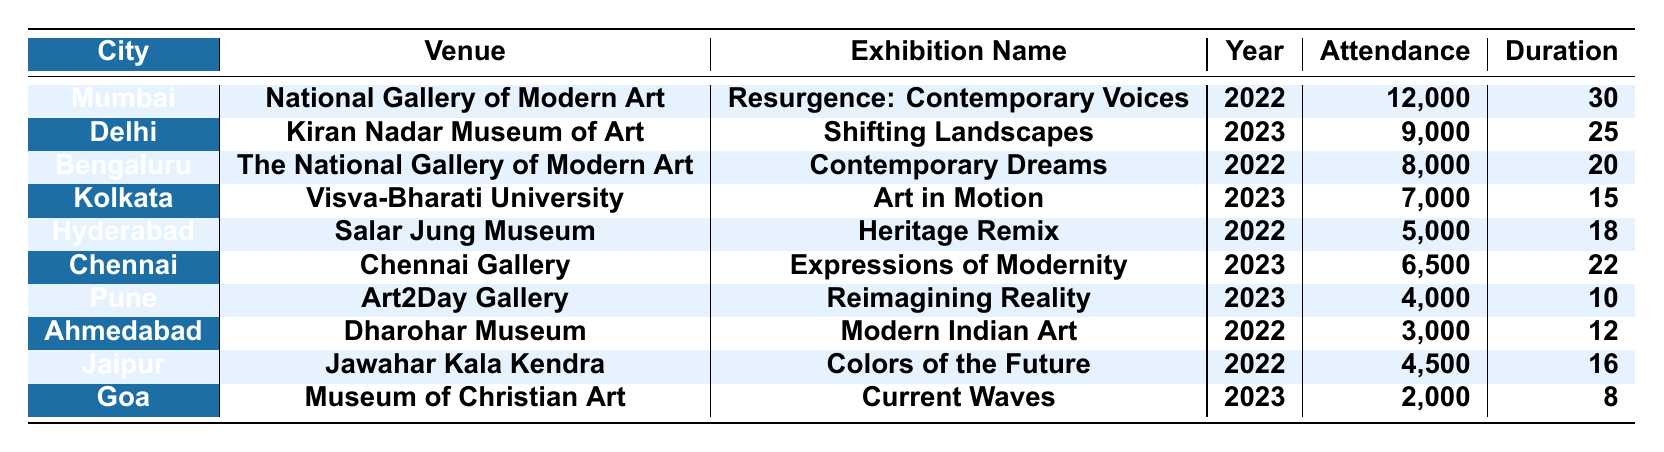What city had the highest attendance at an exhibition? Mumbai had the highest attendance at the "Resurgence: Contemporary Voices" exhibition with 12,000 attendees.
Answer: Mumbai Which exhibition had the lowest attendance? The "Current Waves" exhibition in Goa had the lowest attendance with 2,000 attendees.
Answer: Current Waves What is the total attendance for exhibitions in Chennai and Pune? The attendance for the "Expressions of Modernity" in Chennai is 6,500 and for "Reimagining Reality" in Pune is 4,000. Adding these, 6,500 + 4,000 = 10,500.
Answer: 10,500 How many cities had exhibitions in 2023? The cities that had exhibitions in 2023 are Delhi, Kolkata, Chennai, Pune, and Goa, totaling 5 cities.
Answer: 5 Which exhibition had a duration of more than 20 days? The "Resurgence: Contemporary Voices" in Mumbai was the only exhibition lasting 30 days, which is more than 20 days.
Answer: Resurgence: Contemporary Voices What was the average attendance for exhibitions in 2022? The attendances for 2022 are 12,000 (Mumbai), 8,000 (Bengaluru), 5,000 (Hyderabad), 3,000 (Ahmedabad), and 4,500 (Jaipur). Adding these gives 12,000 + 8,000 + 5,000 + 3,000 + 4,500 = 32,500. Dividing by 5 (the number of exhibitions) gives an average of 6,500.
Answer: 6,500 Is the "Art in Motion" exhibition attendance higher than the total attendance of exhibitions in Ahmedabad and Goa combined? "Art in Motion" had an attendance of 7,000. The combined attendance of "Modern Indian Art" (3,000) and "Current Waves" (2,000) is 5,000. Since 7,000 is greater than 5,000, the statement is true.
Answer: Yes What was the total duration of all exhibitions held in 2023? The durations for 2023 are 25 days (Delhi), 15 days (Kolkata), 22 days (Chennai), 10 days (Pune), and 8 days (Goa). Adding these gives 25 + 15 + 22 + 10 + 8 = 80 days.
Answer: 80 Which city had an exhibition lasting the shortest duration, and what was that duration? Pune had an exhibition "Reimagining Reality" lasting the shortest duration of 10 days.
Answer: Pune, 10 days 